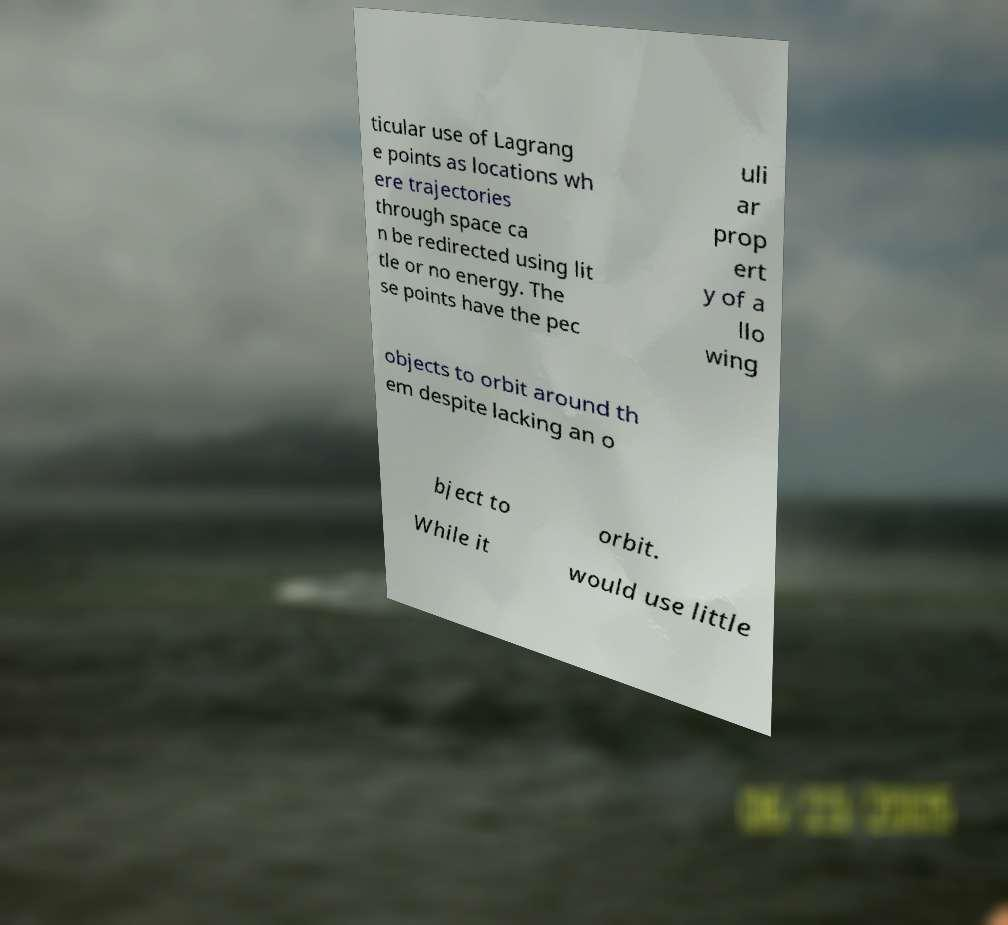Could you assist in decoding the text presented in this image and type it out clearly? ticular use of Lagrang e points as locations wh ere trajectories through space ca n be redirected using lit tle or no energy. The se points have the pec uli ar prop ert y of a llo wing objects to orbit around th em despite lacking an o bject to orbit. While it would use little 